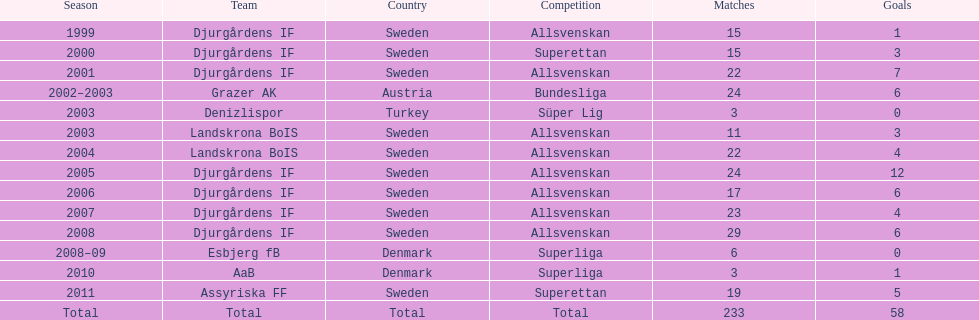In his initial season, how many contests did jones kusi-asare take part in? 15. 